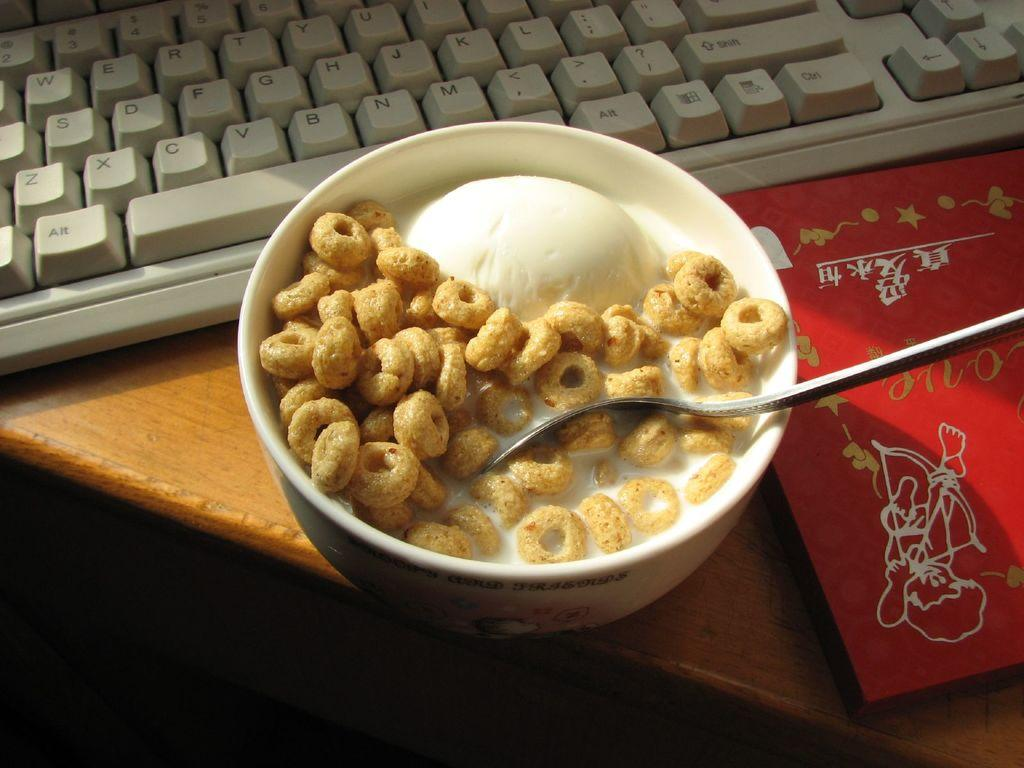What is in the bowl that is visible in the image? There is a food item in the bowl that is visible in the image. What other items can be seen in the image besides the bowl? There is a red color book and a keyboard visible in the image. On what surface are the objects placed in the image? The objects are on a wooden table in the image. What type of quartz is used as a decorative element on the keyboard in the image? There is no quartz present in the image, and the keyboard does not have any decorative elements. 